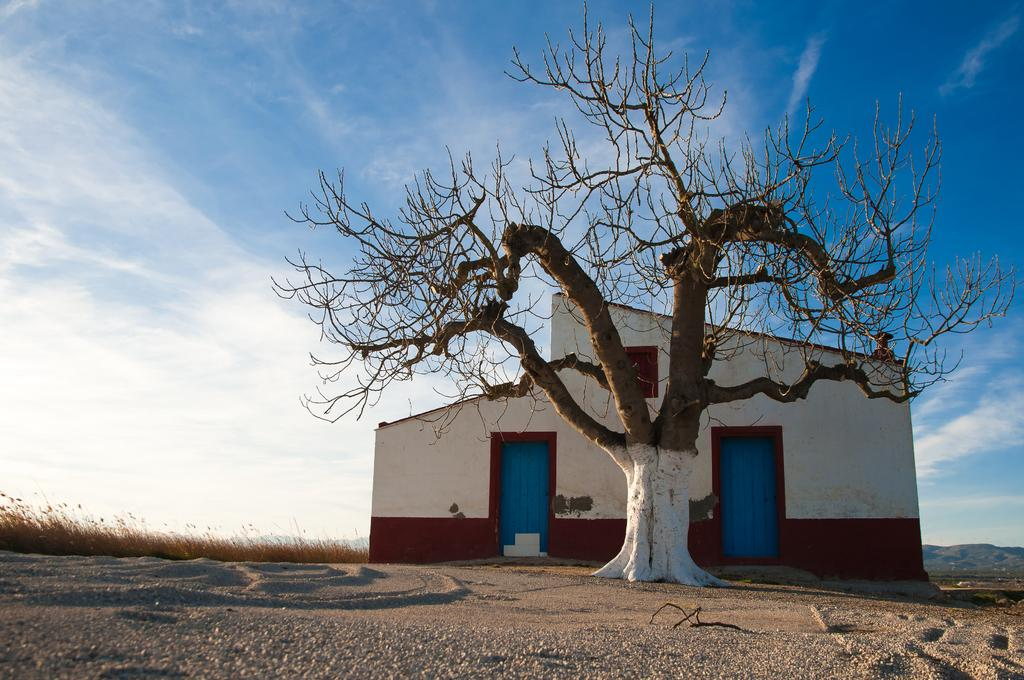What is the largest object on the ground in the image? There is a huge tree on the ground in the image. How many doors are on the wall in the image? There is a wall with 2 doors in the image. What type of vegetation is present in the image? Grass is present in the image. What type of terrain is visible in the image? Sand is visible in the image, and there are hills in the image. What color is the sky in the image? The sky is blue in the image. What type of tray is being used for the voyage in the image? There is no tray or voyage present in the image. 